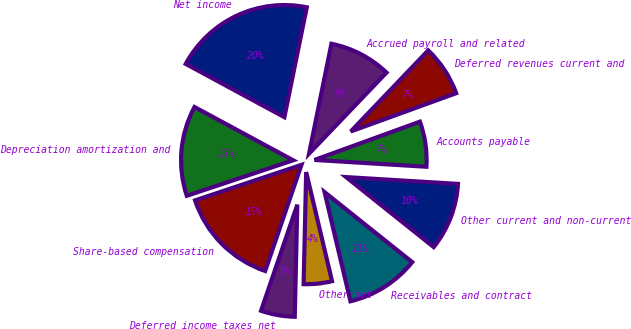Convert chart to OTSL. <chart><loc_0><loc_0><loc_500><loc_500><pie_chart><fcel>Net income<fcel>Depreciation amortization and<fcel>Share-based compensation<fcel>Deferred income taxes net<fcel>Other net<fcel>Receivables and contract<fcel>Other current and non-current<fcel>Accounts payable<fcel>Deferred revenues current and<fcel>Accrued payroll and related<nl><fcel>20.32%<fcel>13.01%<fcel>14.63%<fcel>4.88%<fcel>4.07%<fcel>10.57%<fcel>9.76%<fcel>6.51%<fcel>7.32%<fcel>8.94%<nl></chart> 